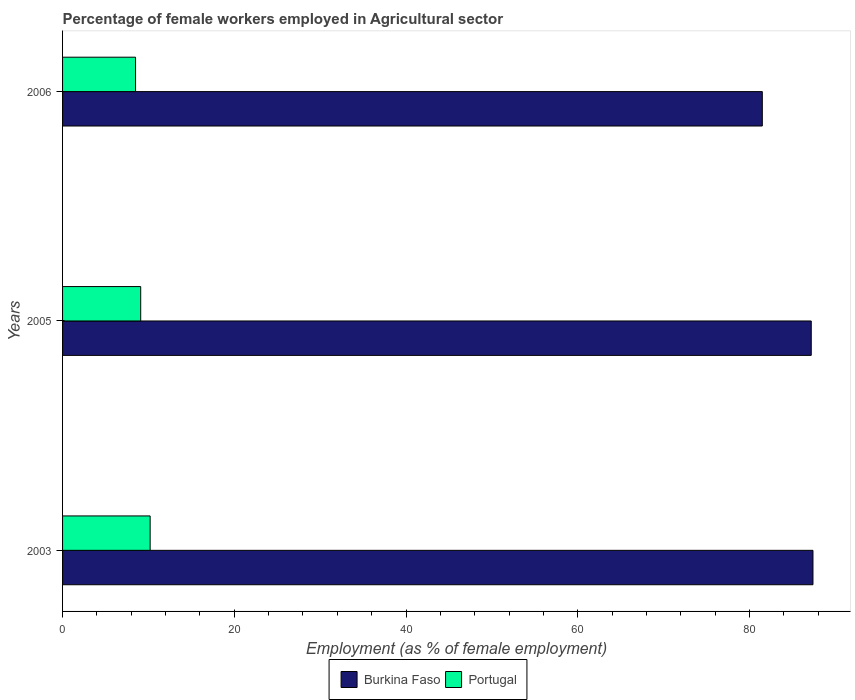How many groups of bars are there?
Offer a terse response. 3. Are the number of bars on each tick of the Y-axis equal?
Keep it short and to the point. Yes. How many bars are there on the 1st tick from the top?
Offer a terse response. 2. How many bars are there on the 2nd tick from the bottom?
Offer a very short reply. 2. What is the label of the 3rd group of bars from the top?
Provide a short and direct response. 2003. What is the percentage of females employed in Agricultural sector in Portugal in 2003?
Make the answer very short. 10.2. Across all years, what is the maximum percentage of females employed in Agricultural sector in Burkina Faso?
Provide a short and direct response. 87.4. Across all years, what is the minimum percentage of females employed in Agricultural sector in Burkina Faso?
Your answer should be compact. 81.5. What is the total percentage of females employed in Agricultural sector in Burkina Faso in the graph?
Your answer should be very brief. 256.1. What is the difference between the percentage of females employed in Agricultural sector in Burkina Faso in 2003 and that in 2006?
Offer a terse response. 5.9. What is the difference between the percentage of females employed in Agricultural sector in Portugal in 2006 and the percentage of females employed in Agricultural sector in Burkina Faso in 2005?
Offer a very short reply. -78.7. What is the average percentage of females employed in Agricultural sector in Burkina Faso per year?
Ensure brevity in your answer.  85.37. In the year 2005, what is the difference between the percentage of females employed in Agricultural sector in Portugal and percentage of females employed in Agricultural sector in Burkina Faso?
Offer a very short reply. -78.1. In how many years, is the percentage of females employed in Agricultural sector in Burkina Faso greater than 32 %?
Offer a very short reply. 3. What is the ratio of the percentage of females employed in Agricultural sector in Portugal in 2005 to that in 2006?
Provide a succinct answer. 1.07. Is the percentage of females employed in Agricultural sector in Portugal in 2003 less than that in 2006?
Offer a terse response. No. Is the difference between the percentage of females employed in Agricultural sector in Portugal in 2003 and 2006 greater than the difference between the percentage of females employed in Agricultural sector in Burkina Faso in 2003 and 2006?
Your response must be concise. No. What is the difference between the highest and the second highest percentage of females employed in Agricultural sector in Burkina Faso?
Your response must be concise. 0.2. What is the difference between the highest and the lowest percentage of females employed in Agricultural sector in Portugal?
Ensure brevity in your answer.  1.7. What does the 1st bar from the bottom in 2006 represents?
Give a very brief answer. Burkina Faso. How many bars are there?
Your answer should be very brief. 6. Are all the bars in the graph horizontal?
Make the answer very short. Yes. How many years are there in the graph?
Ensure brevity in your answer.  3. What is the difference between two consecutive major ticks on the X-axis?
Your answer should be compact. 20. Where does the legend appear in the graph?
Offer a very short reply. Bottom center. What is the title of the graph?
Make the answer very short. Percentage of female workers employed in Agricultural sector. What is the label or title of the X-axis?
Offer a very short reply. Employment (as % of female employment). What is the label or title of the Y-axis?
Ensure brevity in your answer.  Years. What is the Employment (as % of female employment) in Burkina Faso in 2003?
Make the answer very short. 87.4. What is the Employment (as % of female employment) in Portugal in 2003?
Provide a succinct answer. 10.2. What is the Employment (as % of female employment) in Burkina Faso in 2005?
Your response must be concise. 87.2. What is the Employment (as % of female employment) of Portugal in 2005?
Your answer should be very brief. 9.1. What is the Employment (as % of female employment) in Burkina Faso in 2006?
Make the answer very short. 81.5. What is the Employment (as % of female employment) of Portugal in 2006?
Your answer should be very brief. 8.5. Across all years, what is the maximum Employment (as % of female employment) of Burkina Faso?
Your response must be concise. 87.4. Across all years, what is the maximum Employment (as % of female employment) of Portugal?
Offer a very short reply. 10.2. Across all years, what is the minimum Employment (as % of female employment) in Burkina Faso?
Your answer should be very brief. 81.5. Across all years, what is the minimum Employment (as % of female employment) in Portugal?
Offer a very short reply. 8.5. What is the total Employment (as % of female employment) in Burkina Faso in the graph?
Give a very brief answer. 256.1. What is the total Employment (as % of female employment) of Portugal in the graph?
Provide a short and direct response. 27.8. What is the difference between the Employment (as % of female employment) of Burkina Faso in 2003 and the Employment (as % of female employment) of Portugal in 2005?
Provide a succinct answer. 78.3. What is the difference between the Employment (as % of female employment) of Burkina Faso in 2003 and the Employment (as % of female employment) of Portugal in 2006?
Provide a short and direct response. 78.9. What is the difference between the Employment (as % of female employment) of Burkina Faso in 2005 and the Employment (as % of female employment) of Portugal in 2006?
Give a very brief answer. 78.7. What is the average Employment (as % of female employment) of Burkina Faso per year?
Your answer should be very brief. 85.37. What is the average Employment (as % of female employment) of Portugal per year?
Make the answer very short. 9.27. In the year 2003, what is the difference between the Employment (as % of female employment) in Burkina Faso and Employment (as % of female employment) in Portugal?
Offer a very short reply. 77.2. In the year 2005, what is the difference between the Employment (as % of female employment) of Burkina Faso and Employment (as % of female employment) of Portugal?
Your answer should be very brief. 78.1. In the year 2006, what is the difference between the Employment (as % of female employment) in Burkina Faso and Employment (as % of female employment) in Portugal?
Your answer should be very brief. 73. What is the ratio of the Employment (as % of female employment) in Portugal in 2003 to that in 2005?
Give a very brief answer. 1.12. What is the ratio of the Employment (as % of female employment) of Burkina Faso in 2003 to that in 2006?
Make the answer very short. 1.07. What is the ratio of the Employment (as % of female employment) in Burkina Faso in 2005 to that in 2006?
Provide a succinct answer. 1.07. What is the ratio of the Employment (as % of female employment) of Portugal in 2005 to that in 2006?
Give a very brief answer. 1.07. What is the difference between the highest and the lowest Employment (as % of female employment) of Burkina Faso?
Keep it short and to the point. 5.9. What is the difference between the highest and the lowest Employment (as % of female employment) in Portugal?
Make the answer very short. 1.7. 